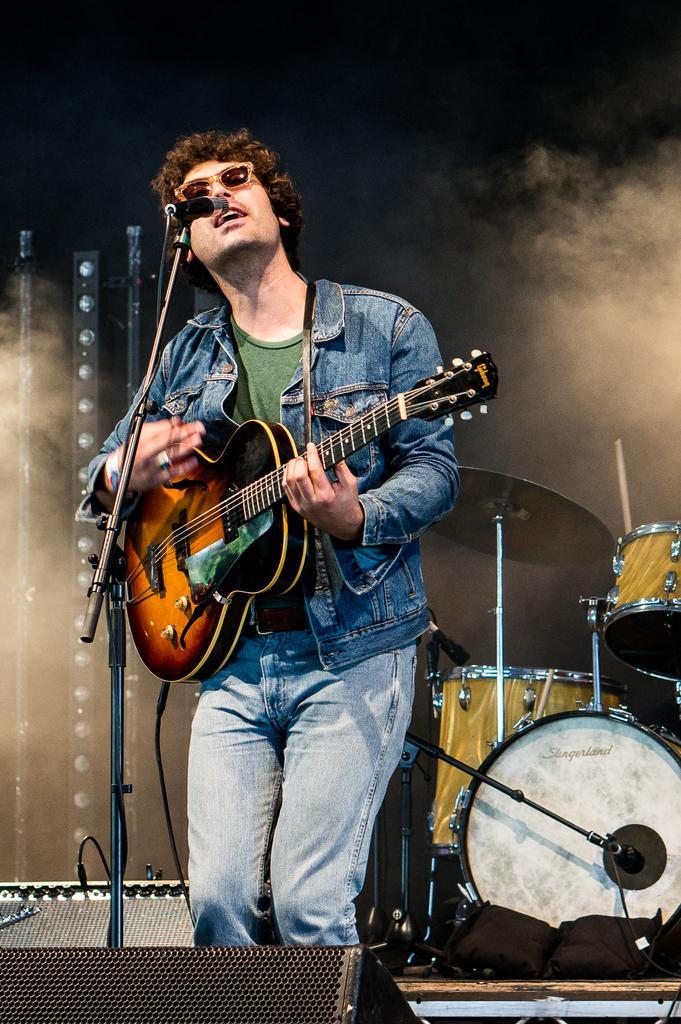Can you describe this image briefly? In this image I can see a person wearing blue and green colored dress is standing and holding a musical instrument in his hand. I can see a microphone in front of him. I can see few lights, few musical instruments and the dark background. 